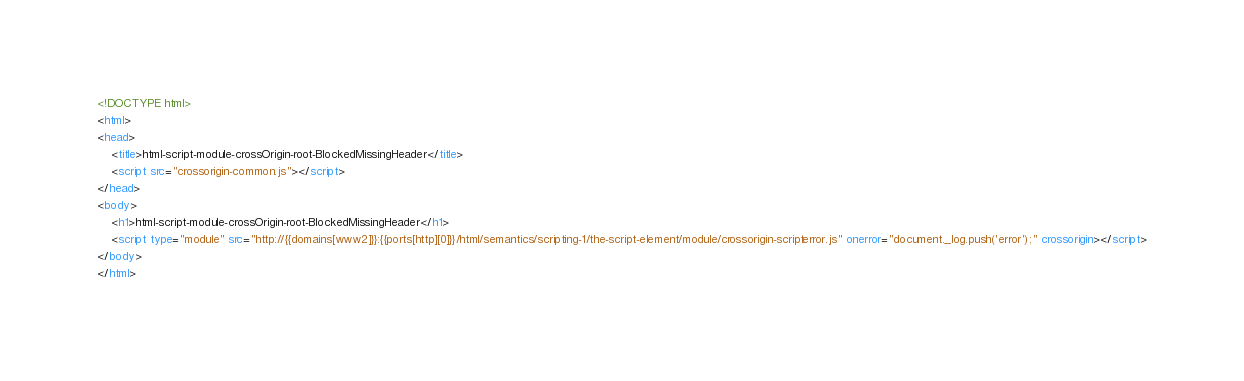Convert code to text. <code><loc_0><loc_0><loc_500><loc_500><_HTML_><!DOCTYPE html>
<html>
<head>
    <title>html-script-module-crossOrigin-root-BlockedMissingHeader</title>
    <script src="crossorigin-common.js"></script>
</head>
<body>
    <h1>html-script-module-crossOrigin-root-BlockedMissingHeader</h1>
    <script type="module" src="http://{{domains[www2]}}:{{ports[http][0]}}/html/semantics/scripting-1/the-script-element/module/crossorigin-scripterror.js" onerror="document._log.push('error');" crossorigin></script>
</body>
</html>
</code> 